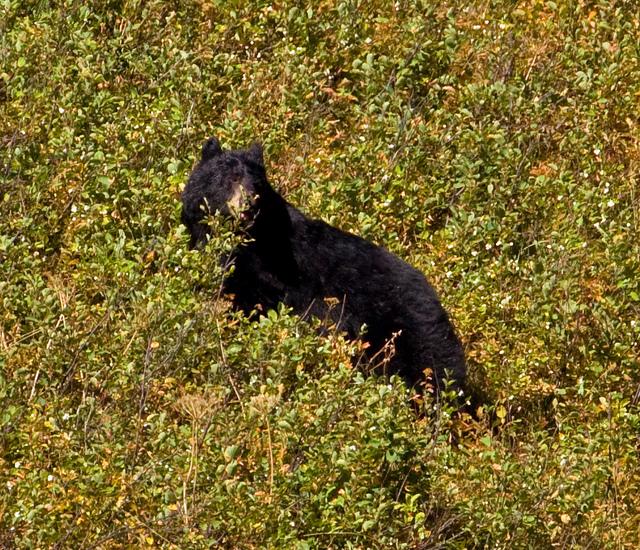Is this bear dangerous?
Write a very short answer. Yes. Do you think this bear caught wind of something?
Quick response, please. Yes. Is this bear on a snowy mountain?
Concise answer only. No. 